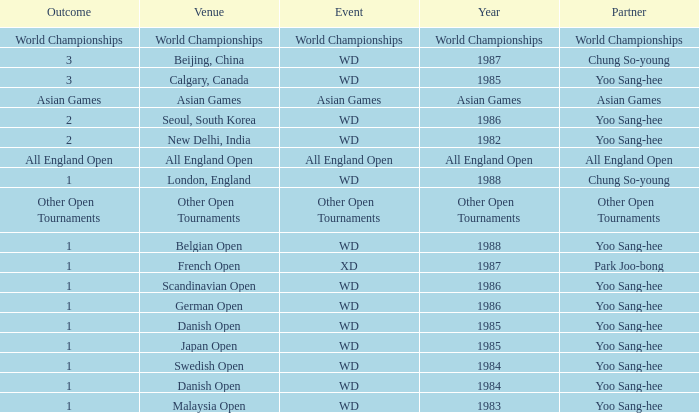In what Year did the German Open have Yoo Sang-Hee as Partner? 1986.0. 